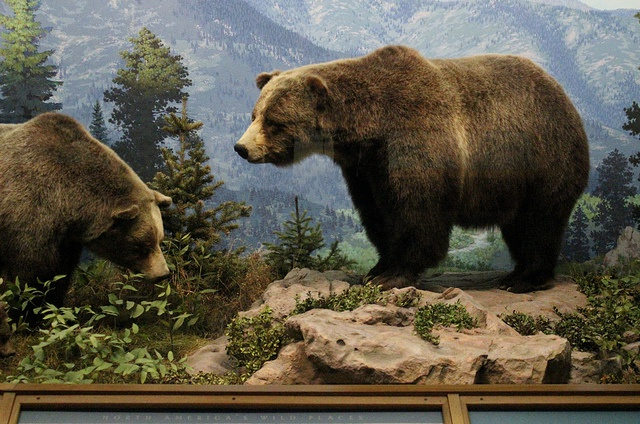Describe the objects in this image and their specific colors. I can see bear in darkgray, black, maroon, and gray tones and bear in darkgray, black, gray, and tan tones in this image. 